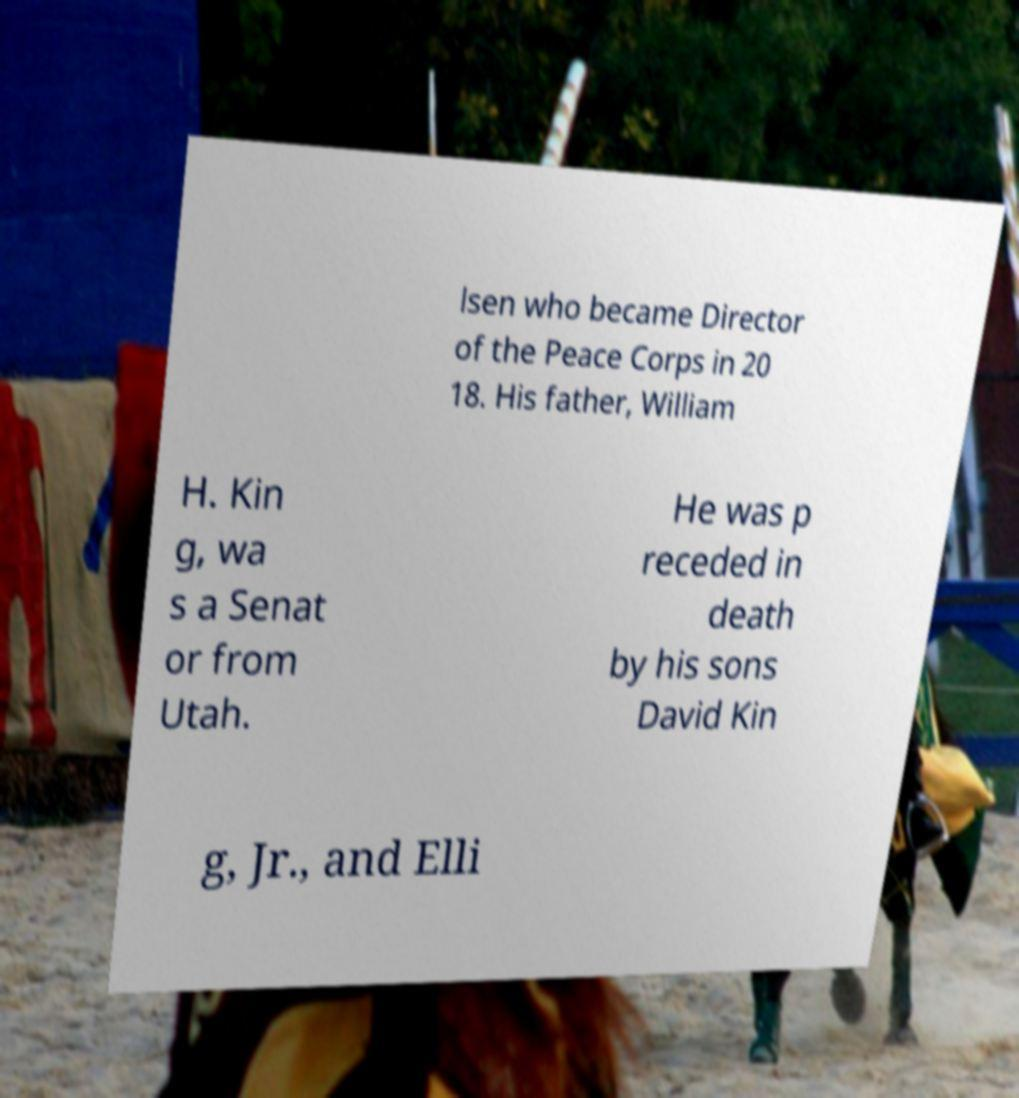Can you accurately transcribe the text from the provided image for me? lsen who became Director of the Peace Corps in 20 18. His father, William H. Kin g, wa s a Senat or from Utah. He was p receded in death by his sons David Kin g, Jr., and Elli 